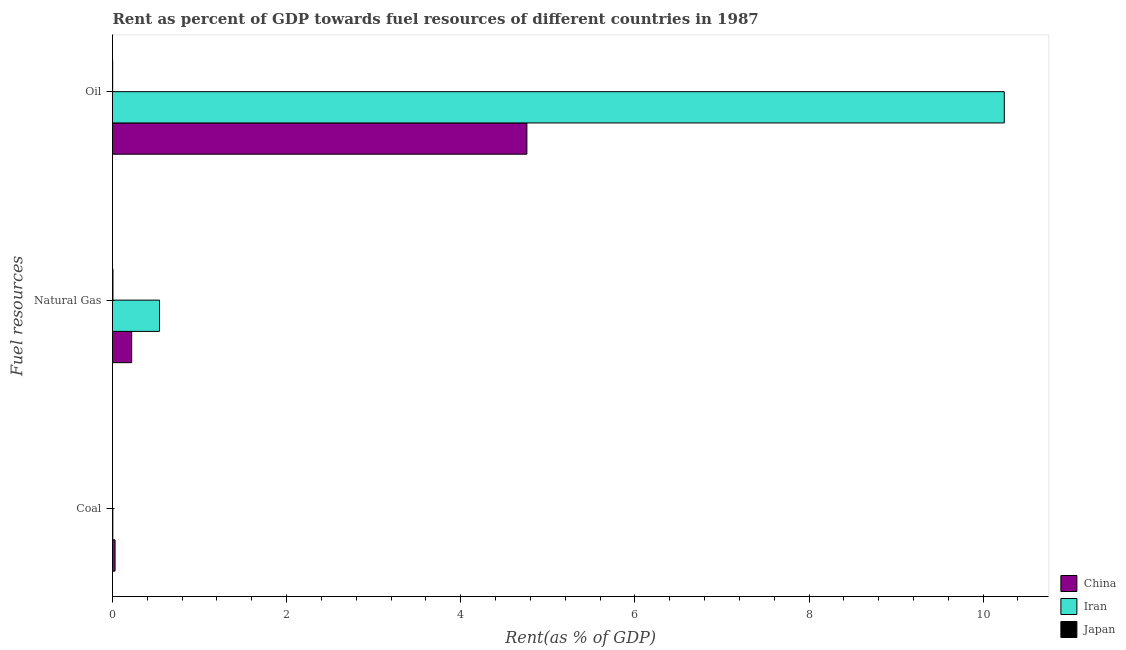Are the number of bars per tick equal to the number of legend labels?
Your answer should be compact. Yes. What is the label of the 1st group of bars from the top?
Your response must be concise. Oil. What is the rent towards natural gas in China?
Your answer should be very brief. 0.22. Across all countries, what is the maximum rent towards coal?
Keep it short and to the point. 0.03. Across all countries, what is the minimum rent towards oil?
Make the answer very short. 0. In which country was the rent towards natural gas maximum?
Your answer should be compact. Iran. In which country was the rent towards natural gas minimum?
Offer a very short reply. Japan. What is the total rent towards coal in the graph?
Ensure brevity in your answer.  0.03. What is the difference between the rent towards natural gas in Japan and that in China?
Provide a succinct answer. -0.21. What is the difference between the rent towards natural gas in China and the rent towards coal in Japan?
Give a very brief answer. 0.22. What is the average rent towards oil per country?
Ensure brevity in your answer.  5. What is the difference between the rent towards natural gas and rent towards oil in China?
Provide a short and direct response. -4.54. What is the ratio of the rent towards coal in Iran to that in China?
Provide a succinct answer. 0.12. Is the rent towards oil in Iran less than that in Japan?
Provide a short and direct response. No. Is the difference between the rent towards coal in China and Japan greater than the difference between the rent towards natural gas in China and Japan?
Offer a terse response. No. What is the difference between the highest and the second highest rent towards natural gas?
Make the answer very short. 0.32. What is the difference between the highest and the lowest rent towards oil?
Provide a succinct answer. 10.24. What does the 3rd bar from the top in Coal represents?
Provide a succinct answer. China. Is it the case that in every country, the sum of the rent towards coal and rent towards natural gas is greater than the rent towards oil?
Offer a very short reply. No. Are all the bars in the graph horizontal?
Give a very brief answer. Yes. Are the values on the major ticks of X-axis written in scientific E-notation?
Give a very brief answer. No. Does the graph contain grids?
Ensure brevity in your answer.  No. Where does the legend appear in the graph?
Your answer should be very brief. Bottom right. How many legend labels are there?
Keep it short and to the point. 3. How are the legend labels stacked?
Offer a very short reply. Vertical. What is the title of the graph?
Provide a short and direct response. Rent as percent of GDP towards fuel resources of different countries in 1987. Does "Puerto Rico" appear as one of the legend labels in the graph?
Your response must be concise. No. What is the label or title of the X-axis?
Your response must be concise. Rent(as % of GDP). What is the label or title of the Y-axis?
Your answer should be very brief. Fuel resources. What is the Rent(as % of GDP) in China in Coal?
Offer a very short reply. 0.03. What is the Rent(as % of GDP) in Iran in Coal?
Ensure brevity in your answer.  0. What is the Rent(as % of GDP) in Japan in Coal?
Give a very brief answer. 9.41219772852493e-7. What is the Rent(as % of GDP) in China in Natural Gas?
Ensure brevity in your answer.  0.22. What is the Rent(as % of GDP) of Iran in Natural Gas?
Your answer should be compact. 0.54. What is the Rent(as % of GDP) in Japan in Natural Gas?
Your answer should be very brief. 0.01. What is the Rent(as % of GDP) in China in Oil?
Keep it short and to the point. 4.76. What is the Rent(as % of GDP) in Iran in Oil?
Make the answer very short. 10.24. What is the Rent(as % of GDP) of Japan in Oil?
Ensure brevity in your answer.  0. Across all Fuel resources, what is the maximum Rent(as % of GDP) of China?
Give a very brief answer. 4.76. Across all Fuel resources, what is the maximum Rent(as % of GDP) of Iran?
Keep it short and to the point. 10.24. Across all Fuel resources, what is the maximum Rent(as % of GDP) in Japan?
Your answer should be compact. 0.01. Across all Fuel resources, what is the minimum Rent(as % of GDP) of China?
Provide a short and direct response. 0.03. Across all Fuel resources, what is the minimum Rent(as % of GDP) in Iran?
Ensure brevity in your answer.  0. Across all Fuel resources, what is the minimum Rent(as % of GDP) of Japan?
Give a very brief answer. 9.41219772852493e-7. What is the total Rent(as % of GDP) in China in the graph?
Provide a succinct answer. 5.01. What is the total Rent(as % of GDP) of Iran in the graph?
Ensure brevity in your answer.  10.79. What is the total Rent(as % of GDP) of Japan in the graph?
Provide a succinct answer. 0.01. What is the difference between the Rent(as % of GDP) of China in Coal and that in Natural Gas?
Your answer should be very brief. -0.19. What is the difference between the Rent(as % of GDP) in Iran in Coal and that in Natural Gas?
Your answer should be very brief. -0.54. What is the difference between the Rent(as % of GDP) of Japan in Coal and that in Natural Gas?
Ensure brevity in your answer.  -0.01. What is the difference between the Rent(as % of GDP) in China in Coal and that in Oil?
Provide a succinct answer. -4.73. What is the difference between the Rent(as % of GDP) of Iran in Coal and that in Oil?
Provide a succinct answer. -10.24. What is the difference between the Rent(as % of GDP) of Japan in Coal and that in Oil?
Ensure brevity in your answer.  -0. What is the difference between the Rent(as % of GDP) in China in Natural Gas and that in Oil?
Provide a short and direct response. -4.54. What is the difference between the Rent(as % of GDP) of Iran in Natural Gas and that in Oil?
Ensure brevity in your answer.  -9.7. What is the difference between the Rent(as % of GDP) of Japan in Natural Gas and that in Oil?
Your response must be concise. 0. What is the difference between the Rent(as % of GDP) of China in Coal and the Rent(as % of GDP) of Iran in Natural Gas?
Offer a very short reply. -0.51. What is the difference between the Rent(as % of GDP) in China in Coal and the Rent(as % of GDP) in Japan in Natural Gas?
Provide a succinct answer. 0.02. What is the difference between the Rent(as % of GDP) in Iran in Coal and the Rent(as % of GDP) in Japan in Natural Gas?
Your response must be concise. -0. What is the difference between the Rent(as % of GDP) in China in Coal and the Rent(as % of GDP) in Iran in Oil?
Keep it short and to the point. -10.21. What is the difference between the Rent(as % of GDP) in China in Coal and the Rent(as % of GDP) in Japan in Oil?
Your answer should be compact. 0.03. What is the difference between the Rent(as % of GDP) in Iran in Coal and the Rent(as % of GDP) in Japan in Oil?
Make the answer very short. 0. What is the difference between the Rent(as % of GDP) of China in Natural Gas and the Rent(as % of GDP) of Iran in Oil?
Keep it short and to the point. -10.02. What is the difference between the Rent(as % of GDP) in China in Natural Gas and the Rent(as % of GDP) in Japan in Oil?
Offer a very short reply. 0.22. What is the difference between the Rent(as % of GDP) of Iran in Natural Gas and the Rent(as % of GDP) of Japan in Oil?
Offer a very short reply. 0.54. What is the average Rent(as % of GDP) of China per Fuel resources?
Your answer should be very brief. 1.67. What is the average Rent(as % of GDP) of Iran per Fuel resources?
Your answer should be compact. 3.6. What is the average Rent(as % of GDP) in Japan per Fuel resources?
Offer a terse response. 0. What is the difference between the Rent(as % of GDP) of China and Rent(as % of GDP) of Iran in Coal?
Offer a terse response. 0.03. What is the difference between the Rent(as % of GDP) of China and Rent(as % of GDP) of Japan in Coal?
Make the answer very short. 0.03. What is the difference between the Rent(as % of GDP) of Iran and Rent(as % of GDP) of Japan in Coal?
Ensure brevity in your answer.  0. What is the difference between the Rent(as % of GDP) of China and Rent(as % of GDP) of Iran in Natural Gas?
Provide a succinct answer. -0.32. What is the difference between the Rent(as % of GDP) of China and Rent(as % of GDP) of Japan in Natural Gas?
Provide a short and direct response. 0.21. What is the difference between the Rent(as % of GDP) in Iran and Rent(as % of GDP) in Japan in Natural Gas?
Provide a short and direct response. 0.54. What is the difference between the Rent(as % of GDP) in China and Rent(as % of GDP) in Iran in Oil?
Your answer should be compact. -5.48. What is the difference between the Rent(as % of GDP) in China and Rent(as % of GDP) in Japan in Oil?
Keep it short and to the point. 4.76. What is the difference between the Rent(as % of GDP) in Iran and Rent(as % of GDP) in Japan in Oil?
Ensure brevity in your answer.  10.24. What is the ratio of the Rent(as % of GDP) in China in Coal to that in Natural Gas?
Ensure brevity in your answer.  0.13. What is the ratio of the Rent(as % of GDP) of Iran in Coal to that in Natural Gas?
Keep it short and to the point. 0.01. What is the ratio of the Rent(as % of GDP) in China in Coal to that in Oil?
Your response must be concise. 0.01. What is the ratio of the Rent(as % of GDP) of Japan in Coal to that in Oil?
Make the answer very short. 0. What is the ratio of the Rent(as % of GDP) in China in Natural Gas to that in Oil?
Provide a succinct answer. 0.05. What is the ratio of the Rent(as % of GDP) of Iran in Natural Gas to that in Oil?
Give a very brief answer. 0.05. What is the ratio of the Rent(as % of GDP) in Japan in Natural Gas to that in Oil?
Make the answer very short. 2.71. What is the difference between the highest and the second highest Rent(as % of GDP) in China?
Give a very brief answer. 4.54. What is the difference between the highest and the second highest Rent(as % of GDP) of Iran?
Keep it short and to the point. 9.7. What is the difference between the highest and the second highest Rent(as % of GDP) of Japan?
Give a very brief answer. 0. What is the difference between the highest and the lowest Rent(as % of GDP) in China?
Offer a very short reply. 4.73. What is the difference between the highest and the lowest Rent(as % of GDP) in Iran?
Keep it short and to the point. 10.24. What is the difference between the highest and the lowest Rent(as % of GDP) of Japan?
Your answer should be compact. 0.01. 